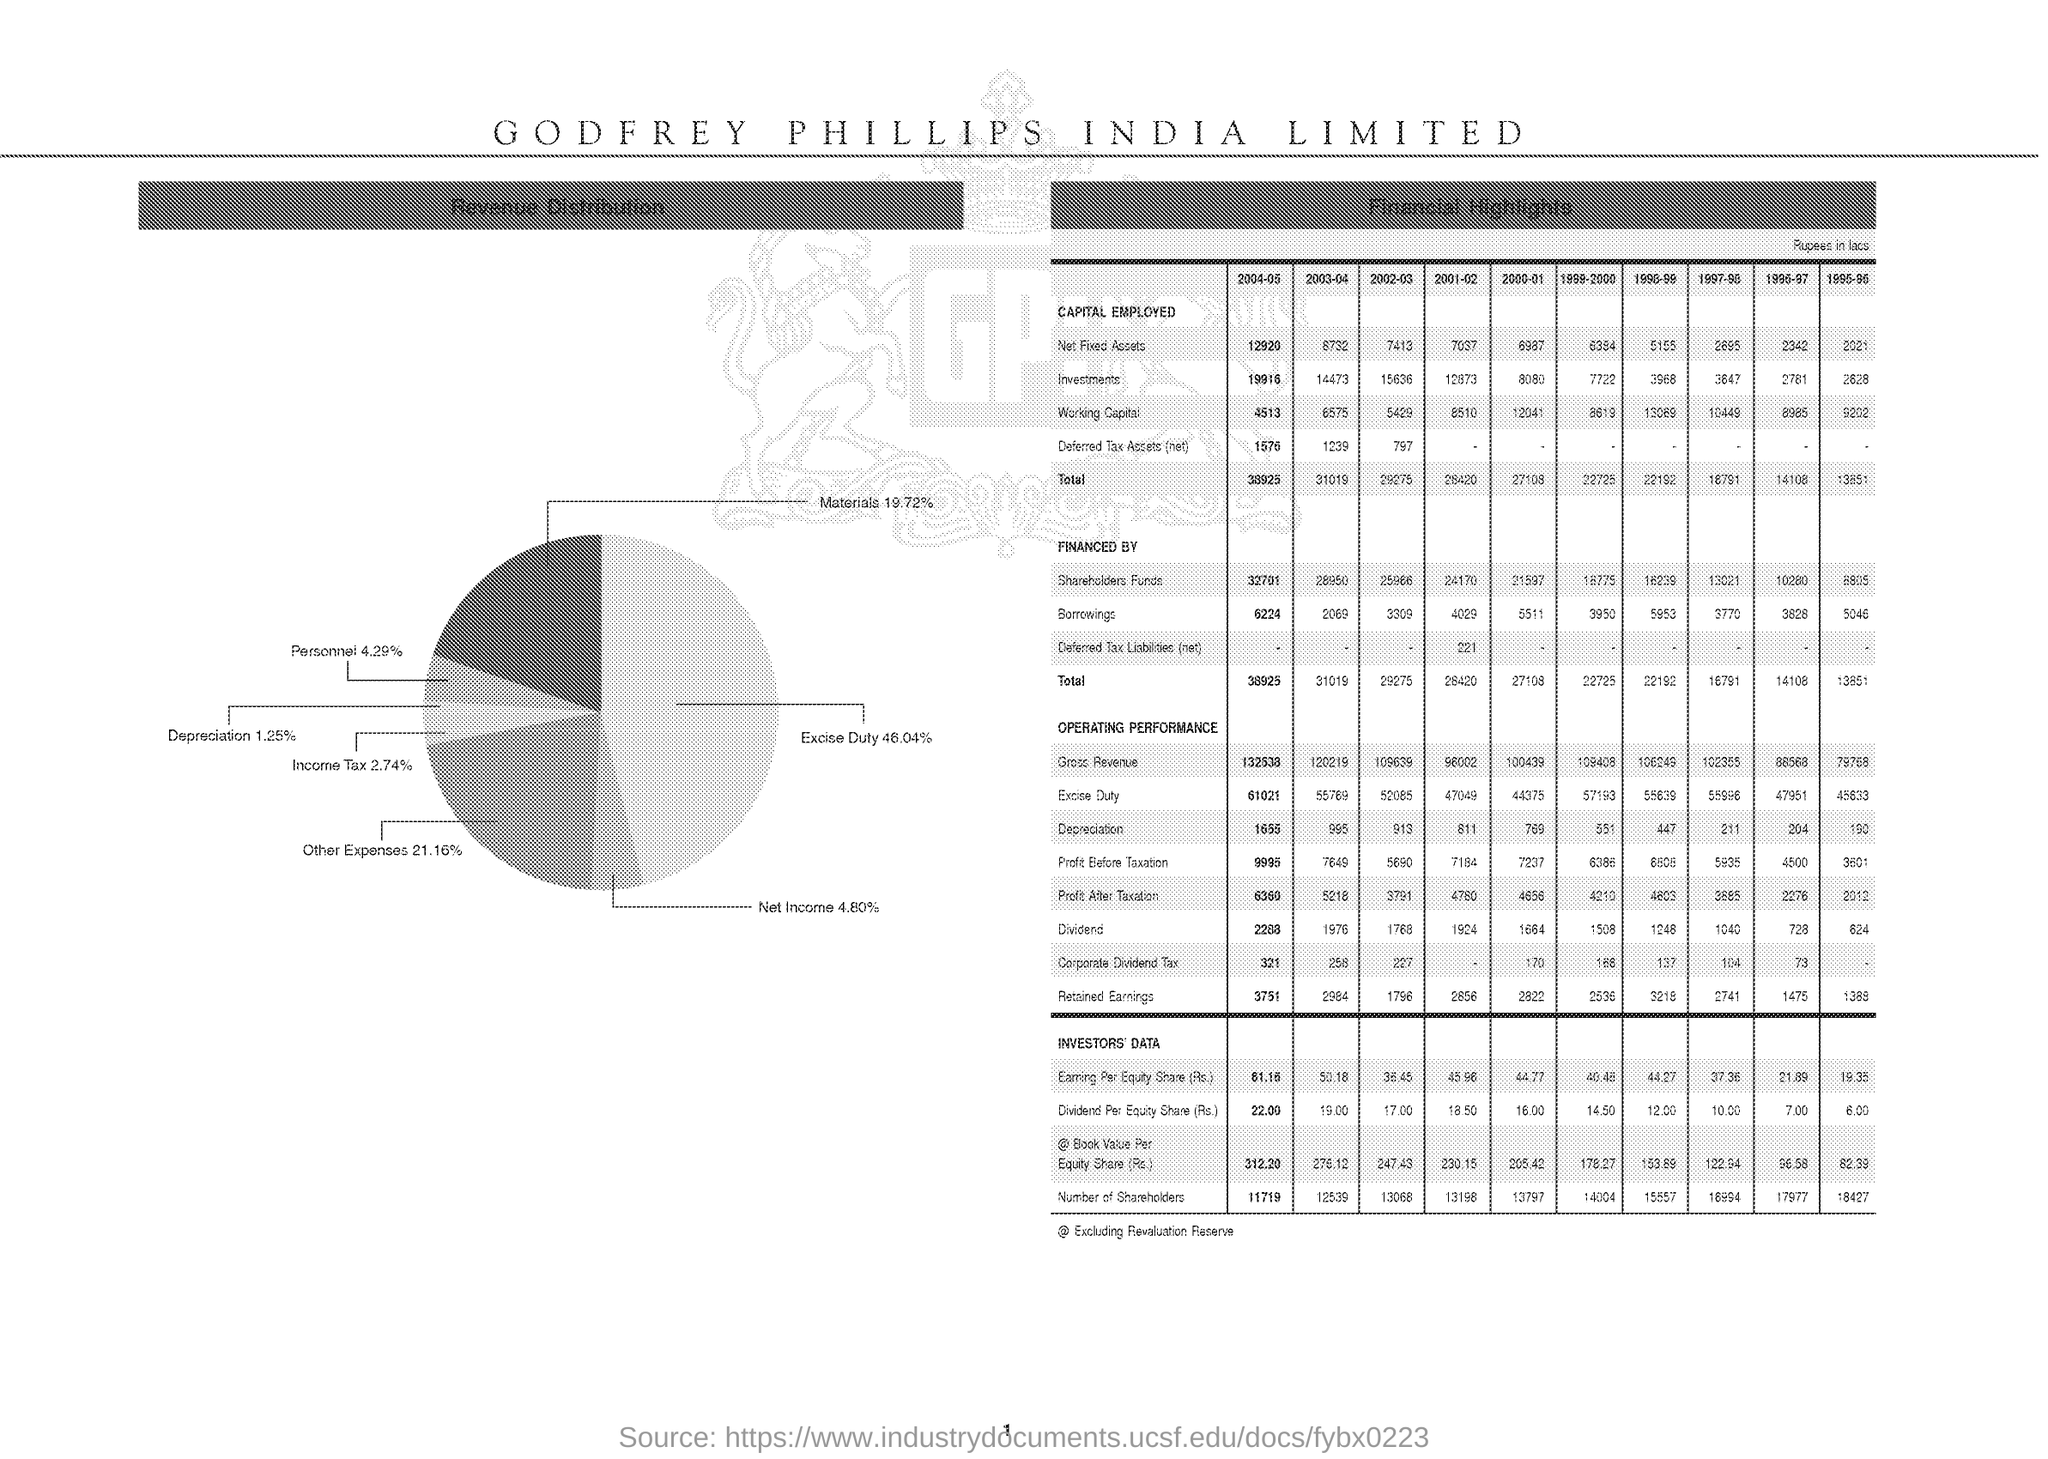What is the excise duty percentage in pie diagram?
Provide a succinct answer. 46.04%. What is the total Capital employed in 2004-05?
Your response must be concise. 38925. 